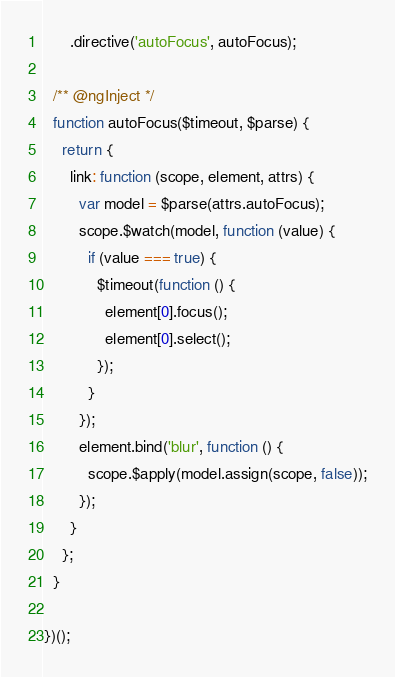<code> <loc_0><loc_0><loc_500><loc_500><_JavaScript_>      .directive('autoFocus', autoFocus);

  /** @ngInject */
  function autoFocus($timeout, $parse) {
    return {
      link: function (scope, element, attrs) {
        var model = $parse(attrs.autoFocus);
        scope.$watch(model, function (value) {
          if (value === true) {
            $timeout(function () {
              element[0].focus();
              element[0].select();
            });
          }
        });
        element.bind('blur', function () {
          scope.$apply(model.assign(scope, false));
        });
      }
    };
  }

})();</code> 